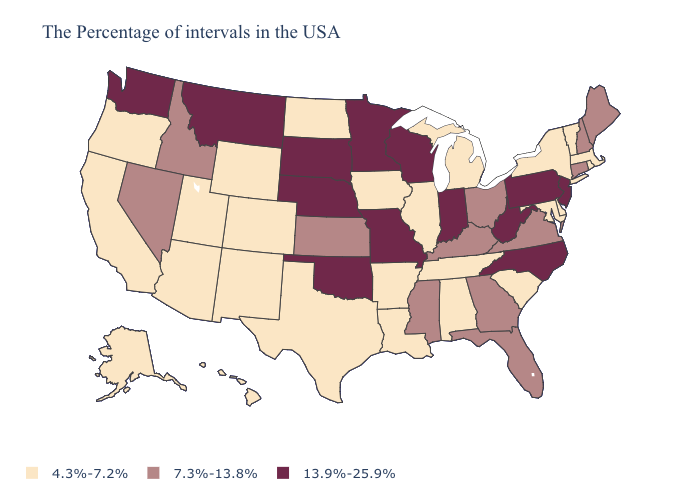Is the legend a continuous bar?
Be succinct. No. What is the lowest value in states that border Washington?
Give a very brief answer. 4.3%-7.2%. What is the value of Kentucky?
Concise answer only. 7.3%-13.8%. What is the highest value in the MidWest ?
Be succinct. 13.9%-25.9%. What is the value of Texas?
Quick response, please. 4.3%-7.2%. What is the highest value in the USA?
Quick response, please. 13.9%-25.9%. Name the states that have a value in the range 7.3%-13.8%?
Answer briefly. Maine, New Hampshire, Connecticut, Virginia, Ohio, Florida, Georgia, Kentucky, Mississippi, Kansas, Idaho, Nevada. What is the value of Kentucky?
Answer briefly. 7.3%-13.8%. Is the legend a continuous bar?
Be succinct. No. What is the value of Colorado?
Quick response, please. 4.3%-7.2%. Does the map have missing data?
Concise answer only. No. What is the highest value in the USA?
Keep it brief. 13.9%-25.9%. Name the states that have a value in the range 4.3%-7.2%?
Write a very short answer. Massachusetts, Rhode Island, Vermont, New York, Delaware, Maryland, South Carolina, Michigan, Alabama, Tennessee, Illinois, Louisiana, Arkansas, Iowa, Texas, North Dakota, Wyoming, Colorado, New Mexico, Utah, Arizona, California, Oregon, Alaska, Hawaii. Name the states that have a value in the range 13.9%-25.9%?
Write a very short answer. New Jersey, Pennsylvania, North Carolina, West Virginia, Indiana, Wisconsin, Missouri, Minnesota, Nebraska, Oklahoma, South Dakota, Montana, Washington. Name the states that have a value in the range 7.3%-13.8%?
Keep it brief. Maine, New Hampshire, Connecticut, Virginia, Ohio, Florida, Georgia, Kentucky, Mississippi, Kansas, Idaho, Nevada. 